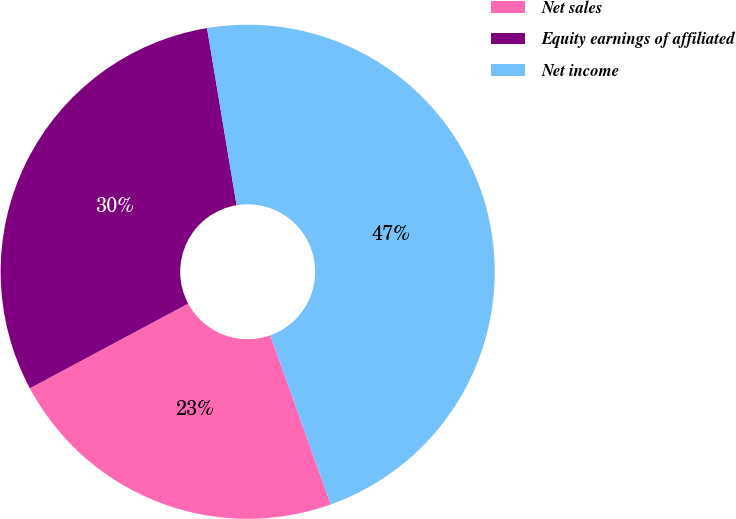<chart> <loc_0><loc_0><loc_500><loc_500><pie_chart><fcel>Net sales<fcel>Equity earnings of affiliated<fcel>Net income<nl><fcel>22.64%<fcel>30.19%<fcel>47.17%<nl></chart> 